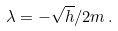Convert formula to latex. <formula><loc_0><loc_0><loc_500><loc_500>\lambda = - \sqrt { h } / 2 m \, .</formula> 